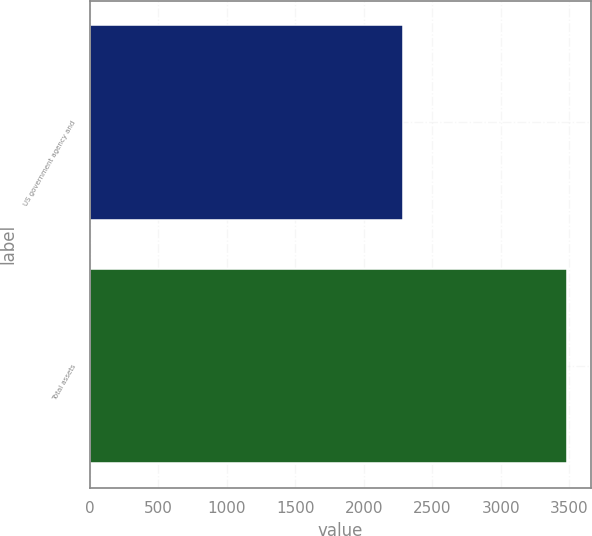Convert chart. <chart><loc_0><loc_0><loc_500><loc_500><bar_chart><fcel>US government agency and<fcel>Total assets<nl><fcel>2282<fcel>3480<nl></chart> 